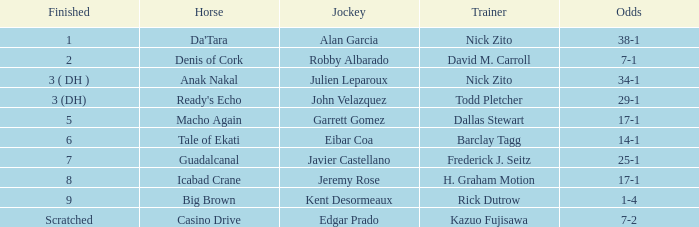What is the Finished place for da'tara trained by Nick zito? 1.0. 